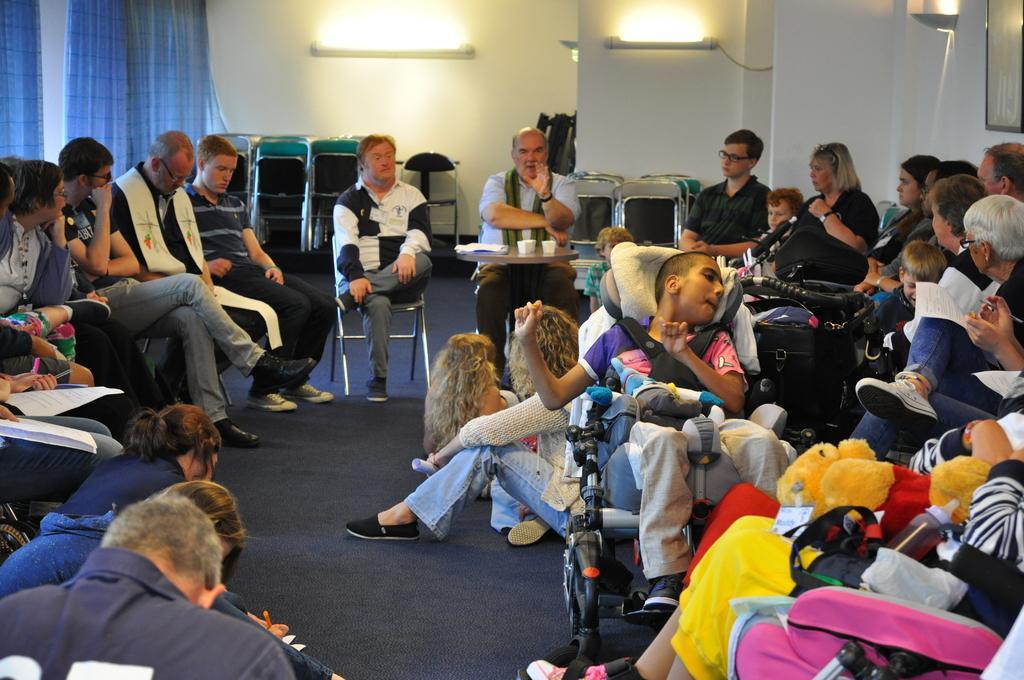How would you summarize this image in a sentence or two? In this image there are a group of persons sitting on the chair, there is a table, there are objects on the table, there are persons holding an object, there is a mat towards the bottom of the image, there are curtains towards the top of the image, there is a wall, there are lights, there is a photo frame towards the right of the image. 